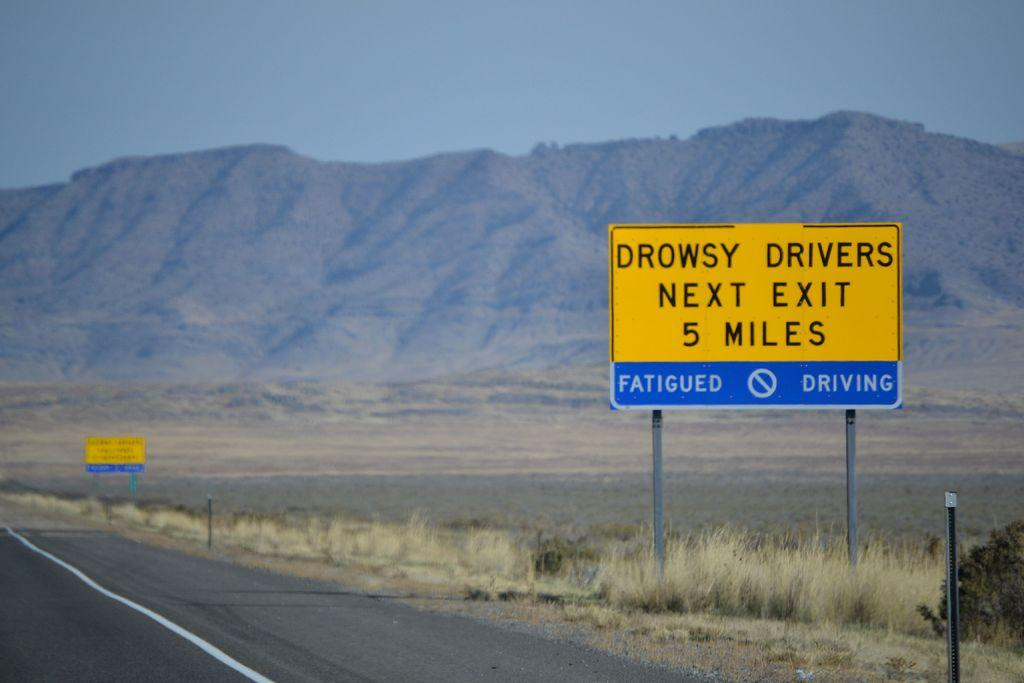<image>
Share a concise interpretation of the image provided. a drowsy drivers message on a yellow sign 